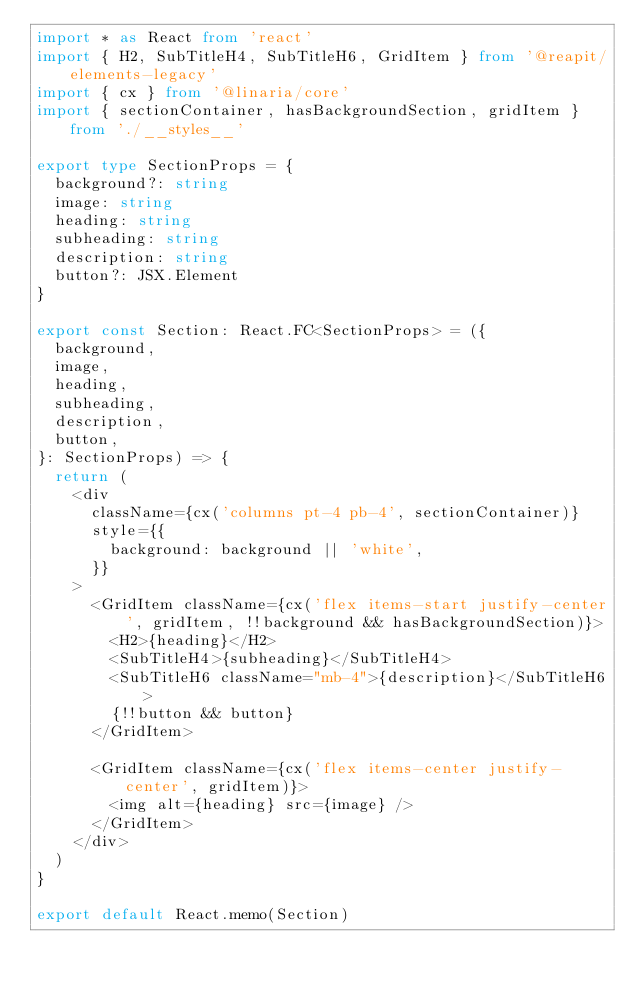<code> <loc_0><loc_0><loc_500><loc_500><_TypeScript_>import * as React from 'react'
import { H2, SubTitleH4, SubTitleH6, GridItem } from '@reapit/elements-legacy'
import { cx } from '@linaria/core'
import { sectionContainer, hasBackgroundSection, gridItem } from './__styles__'

export type SectionProps = {
  background?: string
  image: string
  heading: string
  subheading: string
  description: string
  button?: JSX.Element
}

export const Section: React.FC<SectionProps> = ({
  background,
  image,
  heading,
  subheading,
  description,
  button,
}: SectionProps) => {
  return (
    <div
      className={cx('columns pt-4 pb-4', sectionContainer)}
      style={{
        background: background || 'white',
      }}
    >
      <GridItem className={cx('flex items-start justify-center', gridItem, !!background && hasBackgroundSection)}>
        <H2>{heading}</H2>
        <SubTitleH4>{subheading}</SubTitleH4>
        <SubTitleH6 className="mb-4">{description}</SubTitleH6>
        {!!button && button}
      </GridItem>

      <GridItem className={cx('flex items-center justify-center', gridItem)}>
        <img alt={heading} src={image} />
      </GridItem>
    </div>
  )
}

export default React.memo(Section)
</code> 